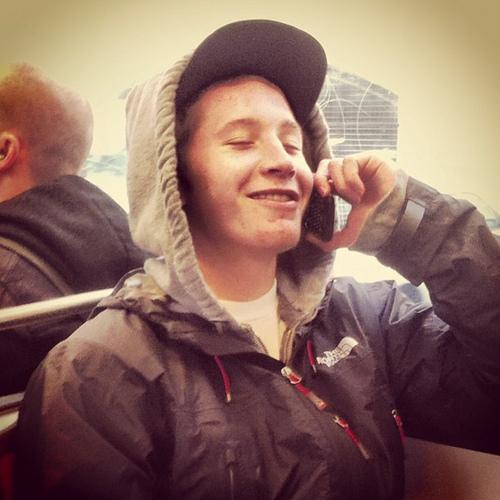How many phones does he have?
Give a very brief answer. 1. 